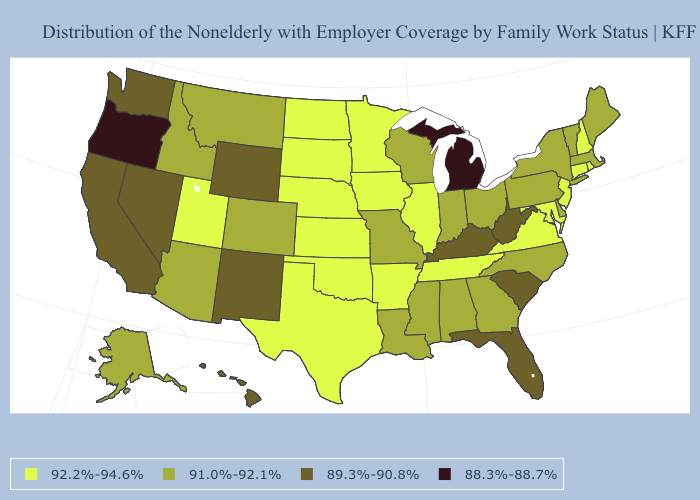What is the value of Montana?
Answer briefly. 91.0%-92.1%. What is the highest value in the USA?
Quick response, please. 92.2%-94.6%. Does Connecticut have the lowest value in the Northeast?
Concise answer only. No. What is the value of Connecticut?
Keep it brief. 92.2%-94.6%. What is the value of Wyoming?
Concise answer only. 89.3%-90.8%. What is the highest value in states that border Illinois?
Give a very brief answer. 92.2%-94.6%. Name the states that have a value in the range 91.0%-92.1%?
Short answer required. Alabama, Alaska, Arizona, Colorado, Delaware, Georgia, Idaho, Indiana, Louisiana, Maine, Massachusetts, Mississippi, Missouri, Montana, New York, North Carolina, Ohio, Pennsylvania, Vermont, Wisconsin. What is the highest value in the South ?
Quick response, please. 92.2%-94.6%. What is the highest value in the Northeast ?
Quick response, please. 92.2%-94.6%. Name the states that have a value in the range 92.2%-94.6%?
Short answer required. Arkansas, Connecticut, Illinois, Iowa, Kansas, Maryland, Minnesota, Nebraska, New Hampshire, New Jersey, North Dakota, Oklahoma, Rhode Island, South Dakota, Tennessee, Texas, Utah, Virginia. Does the map have missing data?
Keep it brief. No. What is the value of Arkansas?
Write a very short answer. 92.2%-94.6%. Which states have the lowest value in the MidWest?
Be succinct. Michigan. What is the highest value in the West ?
Write a very short answer. 92.2%-94.6%. Does New York have the highest value in the Northeast?
Short answer required. No. 